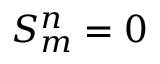<formula> <loc_0><loc_0><loc_500><loc_500>S _ { m } ^ { n } = 0</formula> 